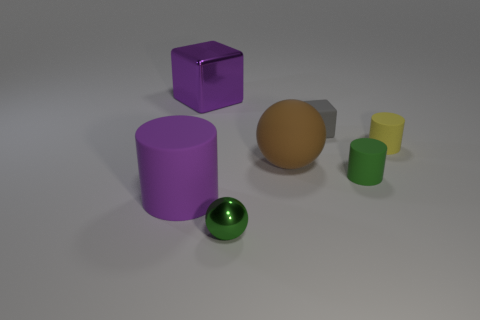Can you tell me what time of the day this scene represents? Based on the lighting in the image, with the soft shadows and neutral background, it suggests an indoor setting with artificial lighting, rather than natural sunlight. Therefore, it's not reflective of a specific time of day. 